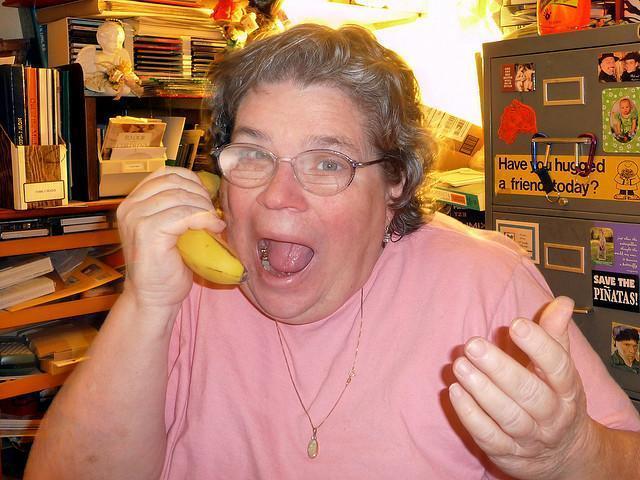How many bananas are there?
Give a very brief answer. 1. How many street signs with a horse in it?
Give a very brief answer. 0. 